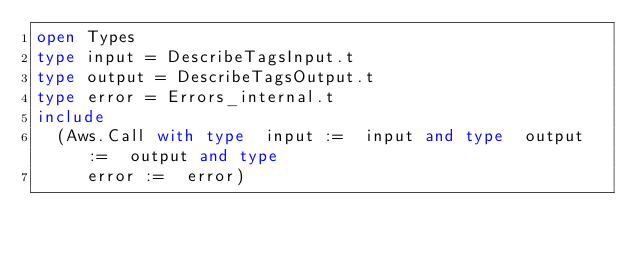Convert code to text. <code><loc_0><loc_0><loc_500><loc_500><_OCaml_>open Types
type input = DescribeTagsInput.t
type output = DescribeTagsOutput.t
type error = Errors_internal.t
include
  (Aws.Call with type  input :=  input and type  output :=  output and type
     error :=  error)</code> 